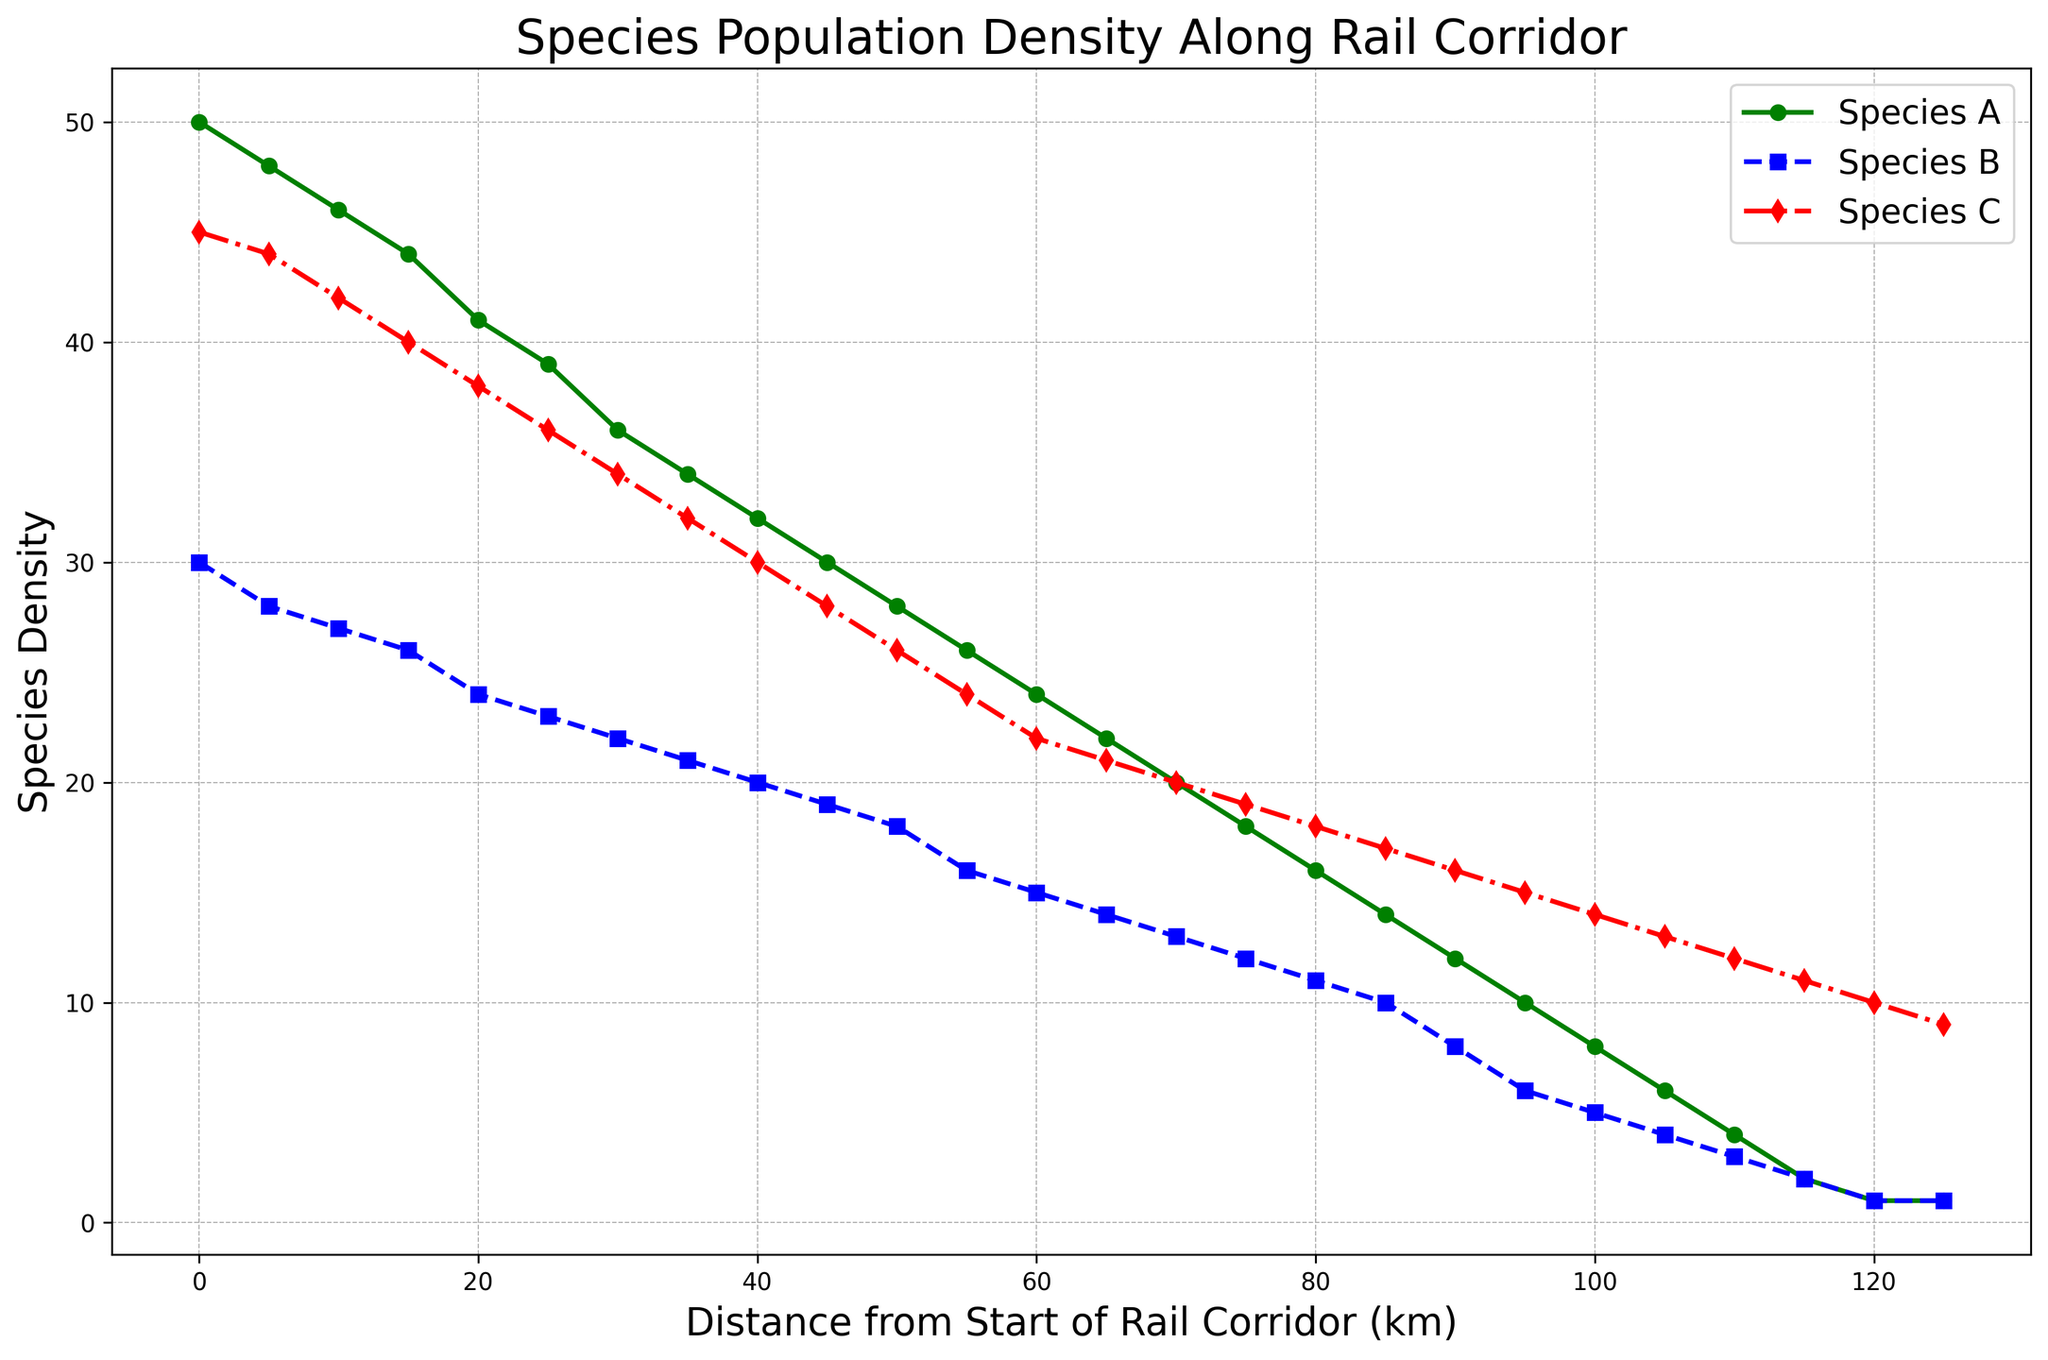Which species has the highest initial density at the start of the corridor? Looking at the plot, find the density values at the start (Distance = 0 km) for Species A, B, and C. Species A has the highest initial density.
Answer: Species A At which distance do all species have the same density? Observe the plot to find the point where the lines for Species A, Species B, and Species C converge. This occurs around the 120 km mark.
Answer: 120 km How does the density of Species C change as you move from 0 km to 100 km? Note the density values of Species C at 0 km and 100 km. At 0 km, it is 45, and at 100 km, it is 14. The density gradually decreases over this distance.
Answer: Decreases What is the average density of Species B over the rail corridor from 0 km to 65 km? Sum the density values of Species B at each 5 km interval from 0 km to 65 km, then divide by the number of intervals. (30+28+27+26+24+23+22+21+20+19+18+16+15+14)/14 = 23.14
Answer: 23.14 Compare the densities of Species A and Species C at the 50 km mark. Which one is higher? Check the plot at 50 km; Species A has a density of 28, and Species C has a density of 26. Species A is higher at this point.
Answer: Species A At what total distance does the density of Species B drop below 10? Check the plot to find where Species B’s density falls below 10. This happens just before the 85 km mark.
Answer: Just before 85 km Estimate the rate of change in density for Species A between 25 km and 50 km. Calculate the difference in density of Species A at 25 km and 50 km and divide by the difference in distance (39-28)/(50-25) = 11/25 = 0.44 per km
Answer: 0.44 per km What can be inferred about the general trend of species densities as the distance from the start increases? Observe the overall trend for all species on the plot. All species show a decreasing density trend as the distance increases from the start.
Answer: Decreasing trend If the trends continue, what would be the expected density of Species C at 130 km? Extrapolate the decreasing trend. At 125 km, the density is 9. With the steady rate of decrease, the density might continue to decrease slightly beyond 9.
Answer: Slightly below 9 Which species exhibits the most significant decline in density over the first 30 km? Compare the slopes of the lines representing Species A, B, and C over the interval from 0 to 30 km. Species C has the steepest slope, indicating the most significant decline.
Answer: Species C 